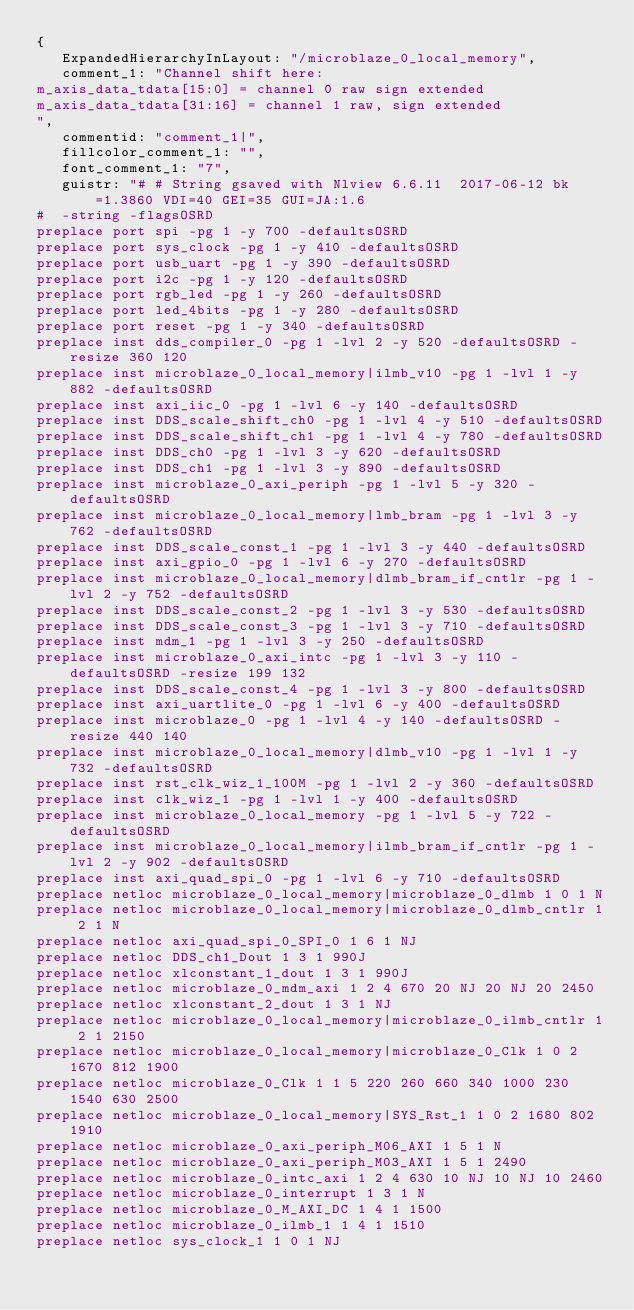Convert code to text. <code><loc_0><loc_0><loc_500><loc_500><_XML_>{
   ExpandedHierarchyInLayout: "/microblaze_0_local_memory",
   comment_1: "Channel shift here:
m_axis_data_tdata[15:0] = channel 0 raw sign extended
m_axis_data_tdata[31:16] = channel 1 raw, sign extended
",
   commentid: "comment_1|",
   fillcolor_comment_1: "",
   font_comment_1: "7",
   guistr: "# # String gsaved with Nlview 6.6.11  2017-06-12 bk=1.3860 VDI=40 GEI=35 GUI=JA:1.6
#  -string -flagsOSRD
preplace port spi -pg 1 -y 700 -defaultsOSRD
preplace port sys_clock -pg 1 -y 410 -defaultsOSRD
preplace port usb_uart -pg 1 -y 390 -defaultsOSRD
preplace port i2c -pg 1 -y 120 -defaultsOSRD
preplace port rgb_led -pg 1 -y 260 -defaultsOSRD
preplace port led_4bits -pg 1 -y 280 -defaultsOSRD
preplace port reset -pg 1 -y 340 -defaultsOSRD
preplace inst dds_compiler_0 -pg 1 -lvl 2 -y 520 -defaultsOSRD -resize 360 120
preplace inst microblaze_0_local_memory|ilmb_v10 -pg 1 -lvl 1 -y 882 -defaultsOSRD
preplace inst axi_iic_0 -pg 1 -lvl 6 -y 140 -defaultsOSRD
preplace inst DDS_scale_shift_ch0 -pg 1 -lvl 4 -y 510 -defaultsOSRD
preplace inst DDS_scale_shift_ch1 -pg 1 -lvl 4 -y 780 -defaultsOSRD
preplace inst DDS_ch0 -pg 1 -lvl 3 -y 620 -defaultsOSRD
preplace inst DDS_ch1 -pg 1 -lvl 3 -y 890 -defaultsOSRD
preplace inst microblaze_0_axi_periph -pg 1 -lvl 5 -y 320 -defaultsOSRD
preplace inst microblaze_0_local_memory|lmb_bram -pg 1 -lvl 3 -y 762 -defaultsOSRD
preplace inst DDS_scale_const_1 -pg 1 -lvl 3 -y 440 -defaultsOSRD
preplace inst axi_gpio_0 -pg 1 -lvl 6 -y 270 -defaultsOSRD
preplace inst microblaze_0_local_memory|dlmb_bram_if_cntlr -pg 1 -lvl 2 -y 752 -defaultsOSRD
preplace inst DDS_scale_const_2 -pg 1 -lvl 3 -y 530 -defaultsOSRD
preplace inst DDS_scale_const_3 -pg 1 -lvl 3 -y 710 -defaultsOSRD
preplace inst mdm_1 -pg 1 -lvl 3 -y 250 -defaultsOSRD
preplace inst microblaze_0_axi_intc -pg 1 -lvl 3 -y 110 -defaultsOSRD -resize 199 132
preplace inst DDS_scale_const_4 -pg 1 -lvl 3 -y 800 -defaultsOSRD
preplace inst axi_uartlite_0 -pg 1 -lvl 6 -y 400 -defaultsOSRD
preplace inst microblaze_0 -pg 1 -lvl 4 -y 140 -defaultsOSRD -resize 440 140
preplace inst microblaze_0_local_memory|dlmb_v10 -pg 1 -lvl 1 -y 732 -defaultsOSRD
preplace inst rst_clk_wiz_1_100M -pg 1 -lvl 2 -y 360 -defaultsOSRD
preplace inst clk_wiz_1 -pg 1 -lvl 1 -y 400 -defaultsOSRD
preplace inst microblaze_0_local_memory -pg 1 -lvl 5 -y 722 -defaultsOSRD
preplace inst microblaze_0_local_memory|ilmb_bram_if_cntlr -pg 1 -lvl 2 -y 902 -defaultsOSRD
preplace inst axi_quad_spi_0 -pg 1 -lvl 6 -y 710 -defaultsOSRD
preplace netloc microblaze_0_local_memory|microblaze_0_dlmb 1 0 1 N
preplace netloc microblaze_0_local_memory|microblaze_0_dlmb_cntlr 1 2 1 N
preplace netloc axi_quad_spi_0_SPI_0 1 6 1 NJ
preplace netloc DDS_ch1_Dout 1 3 1 990J
preplace netloc xlconstant_1_dout 1 3 1 990J
preplace netloc microblaze_0_mdm_axi 1 2 4 670 20 NJ 20 NJ 20 2450
preplace netloc xlconstant_2_dout 1 3 1 NJ
preplace netloc microblaze_0_local_memory|microblaze_0_ilmb_cntlr 1 2 1 2150
preplace netloc microblaze_0_local_memory|microblaze_0_Clk 1 0 2 1670 812 1900
preplace netloc microblaze_0_Clk 1 1 5 220 260 660 340 1000 230 1540 630 2500
preplace netloc microblaze_0_local_memory|SYS_Rst_1 1 0 2 1680 802 1910
preplace netloc microblaze_0_axi_periph_M06_AXI 1 5 1 N
preplace netloc microblaze_0_axi_periph_M03_AXI 1 5 1 2490
preplace netloc microblaze_0_intc_axi 1 2 4 630 10 NJ 10 NJ 10 2460
preplace netloc microblaze_0_interrupt 1 3 1 N
preplace netloc microblaze_0_M_AXI_DC 1 4 1 1500
preplace netloc microblaze_0_ilmb_1 1 4 1 1510
preplace netloc sys_clock_1 1 0 1 NJ</code> 